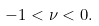Convert formula to latex. <formula><loc_0><loc_0><loc_500><loc_500>- 1 < \nu < 0 .</formula> 